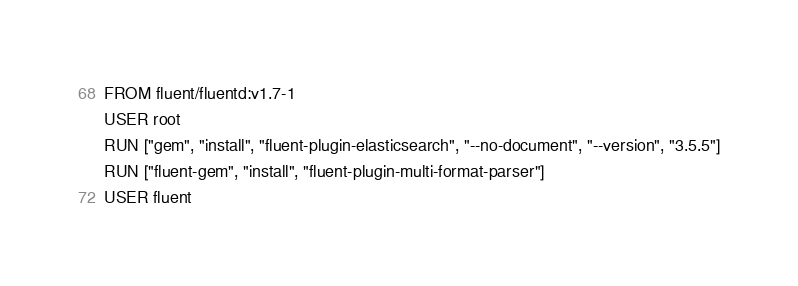<code> <loc_0><loc_0><loc_500><loc_500><_Dockerfile_>FROM fluent/fluentd:v1.7-1
USER root
RUN ["gem", "install", "fluent-plugin-elasticsearch", "--no-document", "--version", "3.5.5"]
RUN ["fluent-gem", "install", "fluent-plugin-multi-format-parser"]
USER fluent
</code> 